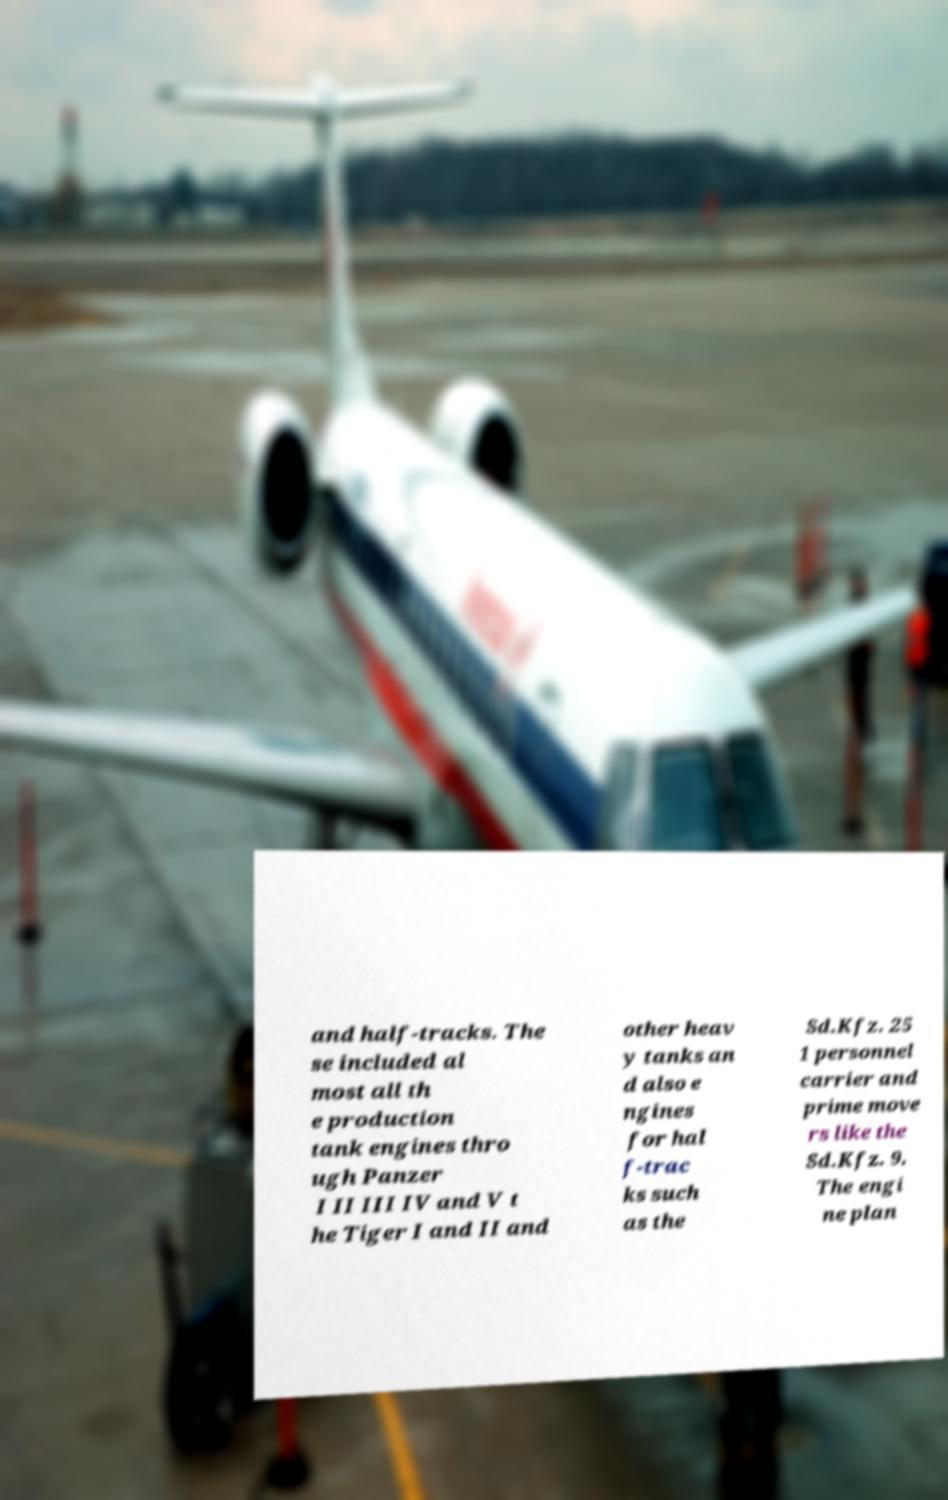For documentation purposes, I need the text within this image transcribed. Could you provide that? and half-tracks. The se included al most all th e production tank engines thro ugh Panzer I II III IV and V t he Tiger I and II and other heav y tanks an d also e ngines for hal f-trac ks such as the Sd.Kfz. 25 1 personnel carrier and prime move rs like the Sd.Kfz. 9. The engi ne plan 